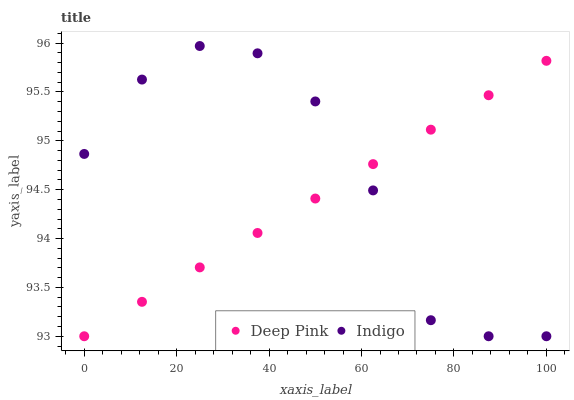Does Deep Pink have the minimum area under the curve?
Answer yes or no. Yes. Does Indigo have the maximum area under the curve?
Answer yes or no. Yes. Does Indigo have the minimum area under the curve?
Answer yes or no. No. Is Deep Pink the smoothest?
Answer yes or no. Yes. Is Indigo the roughest?
Answer yes or no. Yes. Is Indigo the smoothest?
Answer yes or no. No. Does Deep Pink have the lowest value?
Answer yes or no. Yes. Does Indigo have the highest value?
Answer yes or no. Yes. Does Indigo intersect Deep Pink?
Answer yes or no. Yes. Is Indigo less than Deep Pink?
Answer yes or no. No. Is Indigo greater than Deep Pink?
Answer yes or no. No. 